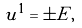Convert formula to latex. <formula><loc_0><loc_0><loc_500><loc_500>u ^ { 1 } = \pm E ,</formula> 